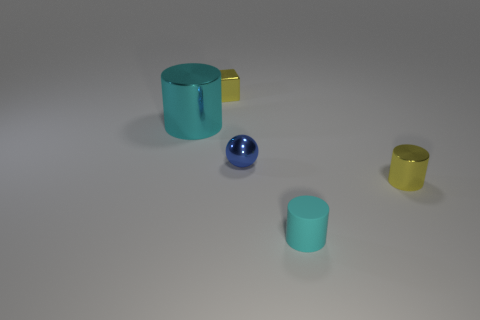Subtract all green cylinders. Subtract all yellow blocks. How many cylinders are left? 3 Add 4 yellow metallic objects. How many objects exist? 9 Subtract all cylinders. How many objects are left? 2 Add 4 blue objects. How many blue objects exist? 5 Subtract 1 blue spheres. How many objects are left? 4 Subtract all tiny yellow cubes. Subtract all shiny things. How many objects are left? 0 Add 5 small yellow metallic cubes. How many small yellow metallic cubes are left? 6 